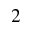Convert formula to latex. <formula><loc_0><loc_0><loc_500><loc_500>2</formula> 